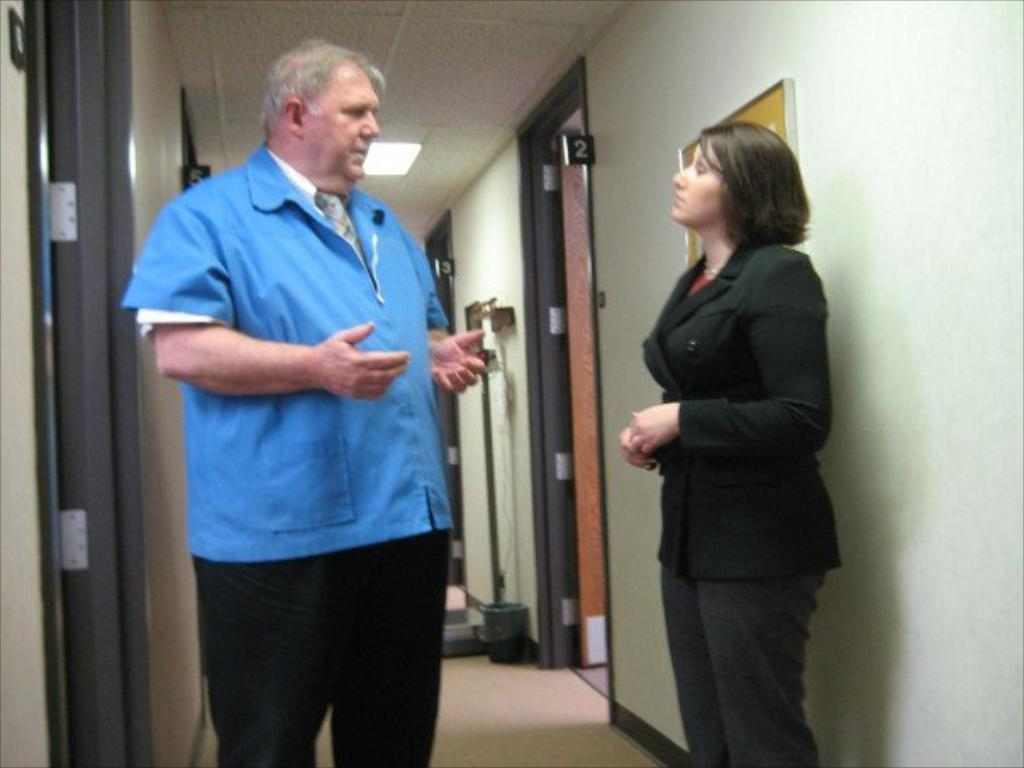Who are the people in the image? There is a man and a woman standing in the image. What can be seen in the background of the image? Doors are visible in the image. What object is on the floor in the image? A dustbin is present on the floor in the image. What is on the wall in the image? There is a board on the wall in the image. What type of lighting is visible in the image? A roof light is visible in the image. What type of jewel is the man wearing on his foot in the image? There is no jewel or any reference to a foot in the image; the man is simply standing with the woman. 